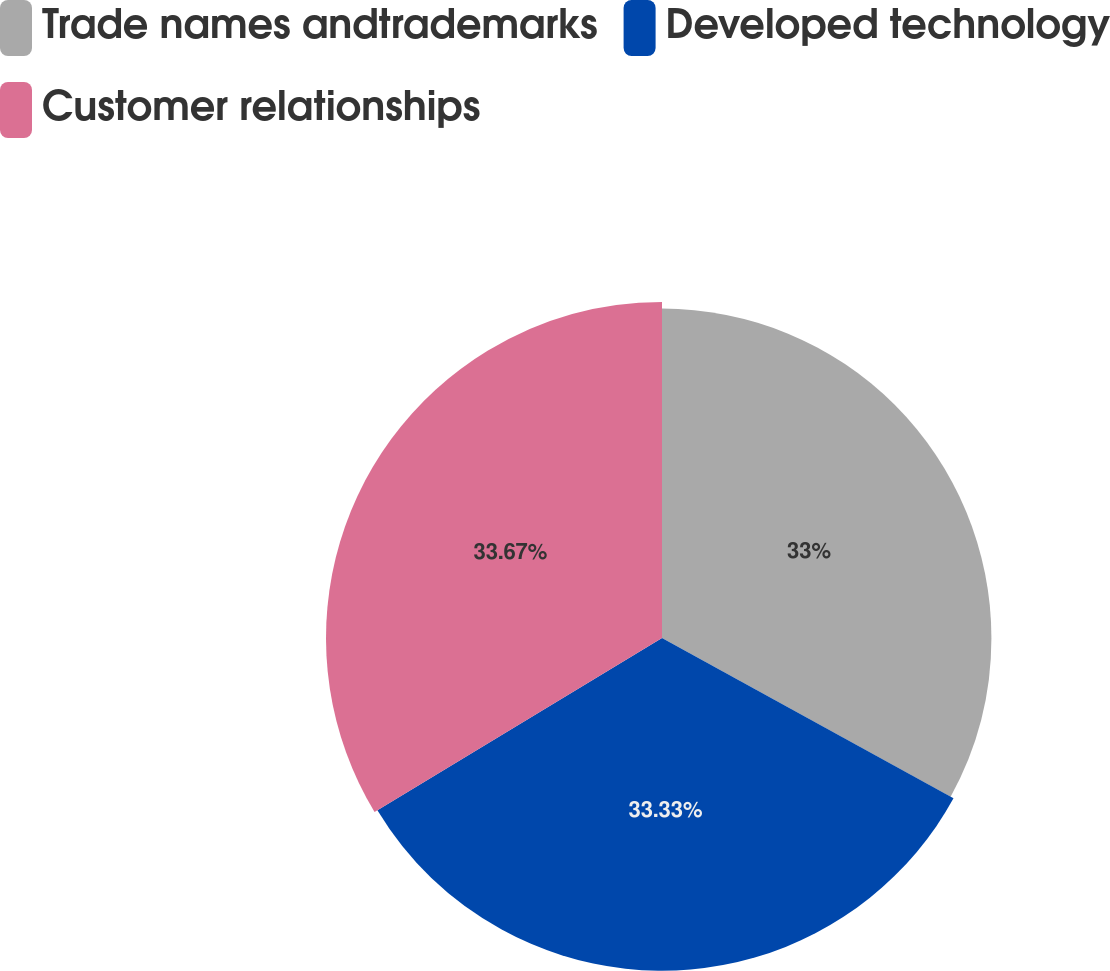<chart> <loc_0><loc_0><loc_500><loc_500><pie_chart><fcel>Trade names andtrademarks<fcel>Developed technology<fcel>Customer relationships<nl><fcel>33.0%<fcel>33.33%<fcel>33.66%<nl></chart> 